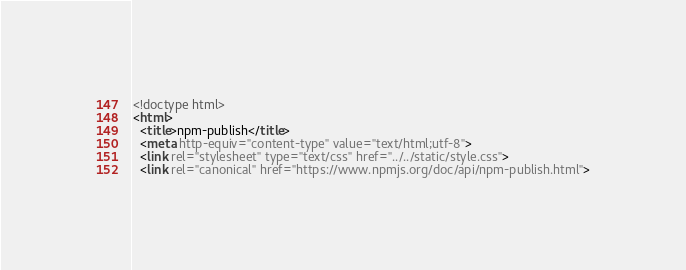<code> <loc_0><loc_0><loc_500><loc_500><_HTML_><!doctype html>
<html>
  <title>npm-publish</title>
  <meta http-equiv="content-type" value="text/html;utf-8">
  <link rel="stylesheet" type="text/css" href="../../static/style.css">
  <link rel="canonical" href="https://www.npmjs.org/doc/api/npm-publish.html"></code> 